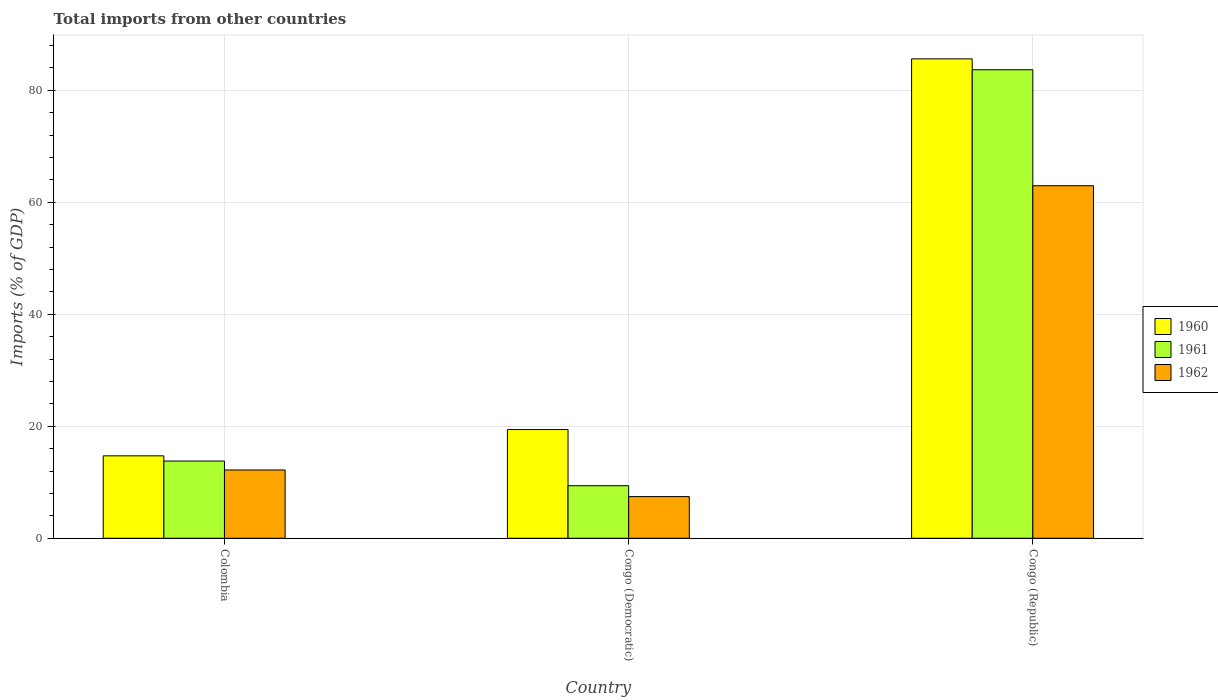How many groups of bars are there?
Offer a terse response. 3. Are the number of bars on each tick of the X-axis equal?
Ensure brevity in your answer.  Yes. How many bars are there on the 1st tick from the left?
Provide a short and direct response. 3. In how many cases, is the number of bars for a given country not equal to the number of legend labels?
Your response must be concise. 0. What is the total imports in 1960 in Congo (Republic)?
Provide a short and direct response. 85.61. Across all countries, what is the maximum total imports in 1961?
Your answer should be very brief. 83.66. Across all countries, what is the minimum total imports in 1962?
Keep it short and to the point. 7.44. In which country was the total imports in 1961 maximum?
Keep it short and to the point. Congo (Republic). In which country was the total imports in 1962 minimum?
Provide a short and direct response. Congo (Democratic). What is the total total imports in 1961 in the graph?
Offer a very short reply. 106.84. What is the difference between the total imports in 1960 in Colombia and that in Congo (Democratic)?
Offer a terse response. -4.7. What is the difference between the total imports in 1960 in Congo (Democratic) and the total imports in 1961 in Congo (Republic)?
Your response must be concise. -64.24. What is the average total imports in 1961 per country?
Your answer should be very brief. 35.61. What is the difference between the total imports of/in 1960 and total imports of/in 1961 in Congo (Democratic)?
Offer a very short reply. 10.03. In how many countries, is the total imports in 1960 greater than 12 %?
Provide a succinct answer. 3. What is the ratio of the total imports in 1962 in Congo (Democratic) to that in Congo (Republic)?
Your answer should be very brief. 0.12. Is the difference between the total imports in 1960 in Colombia and Congo (Democratic) greater than the difference between the total imports in 1961 in Colombia and Congo (Democratic)?
Offer a terse response. No. What is the difference between the highest and the second highest total imports in 1961?
Your answer should be very brief. -74.27. What is the difference between the highest and the lowest total imports in 1960?
Give a very brief answer. 70.89. In how many countries, is the total imports in 1962 greater than the average total imports in 1962 taken over all countries?
Give a very brief answer. 1. Is the sum of the total imports in 1961 in Colombia and Congo (Republic) greater than the maximum total imports in 1962 across all countries?
Provide a succinct answer. Yes. Are all the bars in the graph horizontal?
Ensure brevity in your answer.  No. How many countries are there in the graph?
Offer a terse response. 3. Are the values on the major ticks of Y-axis written in scientific E-notation?
Your answer should be compact. No. How are the legend labels stacked?
Provide a short and direct response. Vertical. What is the title of the graph?
Provide a succinct answer. Total imports from other countries. Does "1964" appear as one of the legend labels in the graph?
Provide a succinct answer. No. What is the label or title of the Y-axis?
Keep it short and to the point. Imports (% of GDP). What is the Imports (% of GDP) of 1960 in Colombia?
Keep it short and to the point. 14.72. What is the Imports (% of GDP) of 1961 in Colombia?
Offer a very short reply. 13.79. What is the Imports (% of GDP) in 1962 in Colombia?
Provide a short and direct response. 12.2. What is the Imports (% of GDP) in 1960 in Congo (Democratic)?
Your answer should be compact. 19.42. What is the Imports (% of GDP) in 1961 in Congo (Democratic)?
Provide a short and direct response. 9.39. What is the Imports (% of GDP) in 1962 in Congo (Democratic)?
Offer a very short reply. 7.44. What is the Imports (% of GDP) in 1960 in Congo (Republic)?
Offer a very short reply. 85.61. What is the Imports (% of GDP) of 1961 in Congo (Republic)?
Your answer should be very brief. 83.66. What is the Imports (% of GDP) of 1962 in Congo (Republic)?
Offer a terse response. 62.95. Across all countries, what is the maximum Imports (% of GDP) of 1960?
Keep it short and to the point. 85.61. Across all countries, what is the maximum Imports (% of GDP) in 1961?
Your response must be concise. 83.66. Across all countries, what is the maximum Imports (% of GDP) in 1962?
Make the answer very short. 62.95. Across all countries, what is the minimum Imports (% of GDP) of 1960?
Offer a very short reply. 14.72. Across all countries, what is the minimum Imports (% of GDP) of 1961?
Provide a succinct answer. 9.39. Across all countries, what is the minimum Imports (% of GDP) in 1962?
Make the answer very short. 7.44. What is the total Imports (% of GDP) in 1960 in the graph?
Your response must be concise. 119.75. What is the total Imports (% of GDP) in 1961 in the graph?
Provide a short and direct response. 106.84. What is the total Imports (% of GDP) in 1962 in the graph?
Your answer should be compact. 82.59. What is the difference between the Imports (% of GDP) of 1960 in Colombia and that in Congo (Democratic)?
Provide a short and direct response. -4.7. What is the difference between the Imports (% of GDP) of 1961 in Colombia and that in Congo (Democratic)?
Your response must be concise. 4.4. What is the difference between the Imports (% of GDP) of 1962 in Colombia and that in Congo (Democratic)?
Give a very brief answer. 4.75. What is the difference between the Imports (% of GDP) in 1960 in Colombia and that in Congo (Republic)?
Your answer should be very brief. -70.89. What is the difference between the Imports (% of GDP) of 1961 in Colombia and that in Congo (Republic)?
Provide a succinct answer. -69.87. What is the difference between the Imports (% of GDP) in 1962 in Colombia and that in Congo (Republic)?
Make the answer very short. -50.76. What is the difference between the Imports (% of GDP) of 1960 in Congo (Democratic) and that in Congo (Republic)?
Offer a very short reply. -66.19. What is the difference between the Imports (% of GDP) in 1961 in Congo (Democratic) and that in Congo (Republic)?
Offer a terse response. -74.27. What is the difference between the Imports (% of GDP) in 1962 in Congo (Democratic) and that in Congo (Republic)?
Your answer should be compact. -55.51. What is the difference between the Imports (% of GDP) of 1960 in Colombia and the Imports (% of GDP) of 1961 in Congo (Democratic)?
Your answer should be compact. 5.33. What is the difference between the Imports (% of GDP) of 1960 in Colombia and the Imports (% of GDP) of 1962 in Congo (Democratic)?
Ensure brevity in your answer.  7.28. What is the difference between the Imports (% of GDP) of 1961 in Colombia and the Imports (% of GDP) of 1962 in Congo (Democratic)?
Ensure brevity in your answer.  6.35. What is the difference between the Imports (% of GDP) in 1960 in Colombia and the Imports (% of GDP) in 1961 in Congo (Republic)?
Ensure brevity in your answer.  -68.94. What is the difference between the Imports (% of GDP) of 1960 in Colombia and the Imports (% of GDP) of 1962 in Congo (Republic)?
Make the answer very short. -48.23. What is the difference between the Imports (% of GDP) in 1961 in Colombia and the Imports (% of GDP) in 1962 in Congo (Republic)?
Ensure brevity in your answer.  -49.16. What is the difference between the Imports (% of GDP) of 1960 in Congo (Democratic) and the Imports (% of GDP) of 1961 in Congo (Republic)?
Provide a short and direct response. -64.24. What is the difference between the Imports (% of GDP) of 1960 in Congo (Democratic) and the Imports (% of GDP) of 1962 in Congo (Republic)?
Make the answer very short. -43.54. What is the difference between the Imports (% of GDP) in 1961 in Congo (Democratic) and the Imports (% of GDP) in 1962 in Congo (Republic)?
Provide a short and direct response. -53.56. What is the average Imports (% of GDP) of 1960 per country?
Give a very brief answer. 39.92. What is the average Imports (% of GDP) of 1961 per country?
Your response must be concise. 35.61. What is the average Imports (% of GDP) in 1962 per country?
Your answer should be compact. 27.53. What is the difference between the Imports (% of GDP) of 1960 and Imports (% of GDP) of 1961 in Colombia?
Keep it short and to the point. 0.93. What is the difference between the Imports (% of GDP) of 1960 and Imports (% of GDP) of 1962 in Colombia?
Keep it short and to the point. 2.53. What is the difference between the Imports (% of GDP) of 1961 and Imports (% of GDP) of 1962 in Colombia?
Keep it short and to the point. 1.6. What is the difference between the Imports (% of GDP) of 1960 and Imports (% of GDP) of 1961 in Congo (Democratic)?
Make the answer very short. 10.03. What is the difference between the Imports (% of GDP) in 1960 and Imports (% of GDP) in 1962 in Congo (Democratic)?
Offer a terse response. 11.98. What is the difference between the Imports (% of GDP) in 1961 and Imports (% of GDP) in 1962 in Congo (Democratic)?
Make the answer very short. 1.95. What is the difference between the Imports (% of GDP) of 1960 and Imports (% of GDP) of 1961 in Congo (Republic)?
Keep it short and to the point. 1.95. What is the difference between the Imports (% of GDP) in 1960 and Imports (% of GDP) in 1962 in Congo (Republic)?
Make the answer very short. 22.66. What is the difference between the Imports (% of GDP) in 1961 and Imports (% of GDP) in 1962 in Congo (Republic)?
Your response must be concise. 20.71. What is the ratio of the Imports (% of GDP) in 1960 in Colombia to that in Congo (Democratic)?
Provide a short and direct response. 0.76. What is the ratio of the Imports (% of GDP) of 1961 in Colombia to that in Congo (Democratic)?
Your response must be concise. 1.47. What is the ratio of the Imports (% of GDP) in 1962 in Colombia to that in Congo (Democratic)?
Ensure brevity in your answer.  1.64. What is the ratio of the Imports (% of GDP) in 1960 in Colombia to that in Congo (Republic)?
Ensure brevity in your answer.  0.17. What is the ratio of the Imports (% of GDP) in 1961 in Colombia to that in Congo (Republic)?
Ensure brevity in your answer.  0.16. What is the ratio of the Imports (% of GDP) of 1962 in Colombia to that in Congo (Republic)?
Your answer should be very brief. 0.19. What is the ratio of the Imports (% of GDP) of 1960 in Congo (Democratic) to that in Congo (Republic)?
Your answer should be very brief. 0.23. What is the ratio of the Imports (% of GDP) of 1961 in Congo (Democratic) to that in Congo (Republic)?
Make the answer very short. 0.11. What is the ratio of the Imports (% of GDP) in 1962 in Congo (Democratic) to that in Congo (Republic)?
Your answer should be very brief. 0.12. What is the difference between the highest and the second highest Imports (% of GDP) of 1960?
Offer a terse response. 66.19. What is the difference between the highest and the second highest Imports (% of GDP) of 1961?
Provide a short and direct response. 69.87. What is the difference between the highest and the second highest Imports (% of GDP) in 1962?
Keep it short and to the point. 50.76. What is the difference between the highest and the lowest Imports (% of GDP) in 1960?
Offer a terse response. 70.89. What is the difference between the highest and the lowest Imports (% of GDP) of 1961?
Keep it short and to the point. 74.27. What is the difference between the highest and the lowest Imports (% of GDP) in 1962?
Provide a succinct answer. 55.51. 